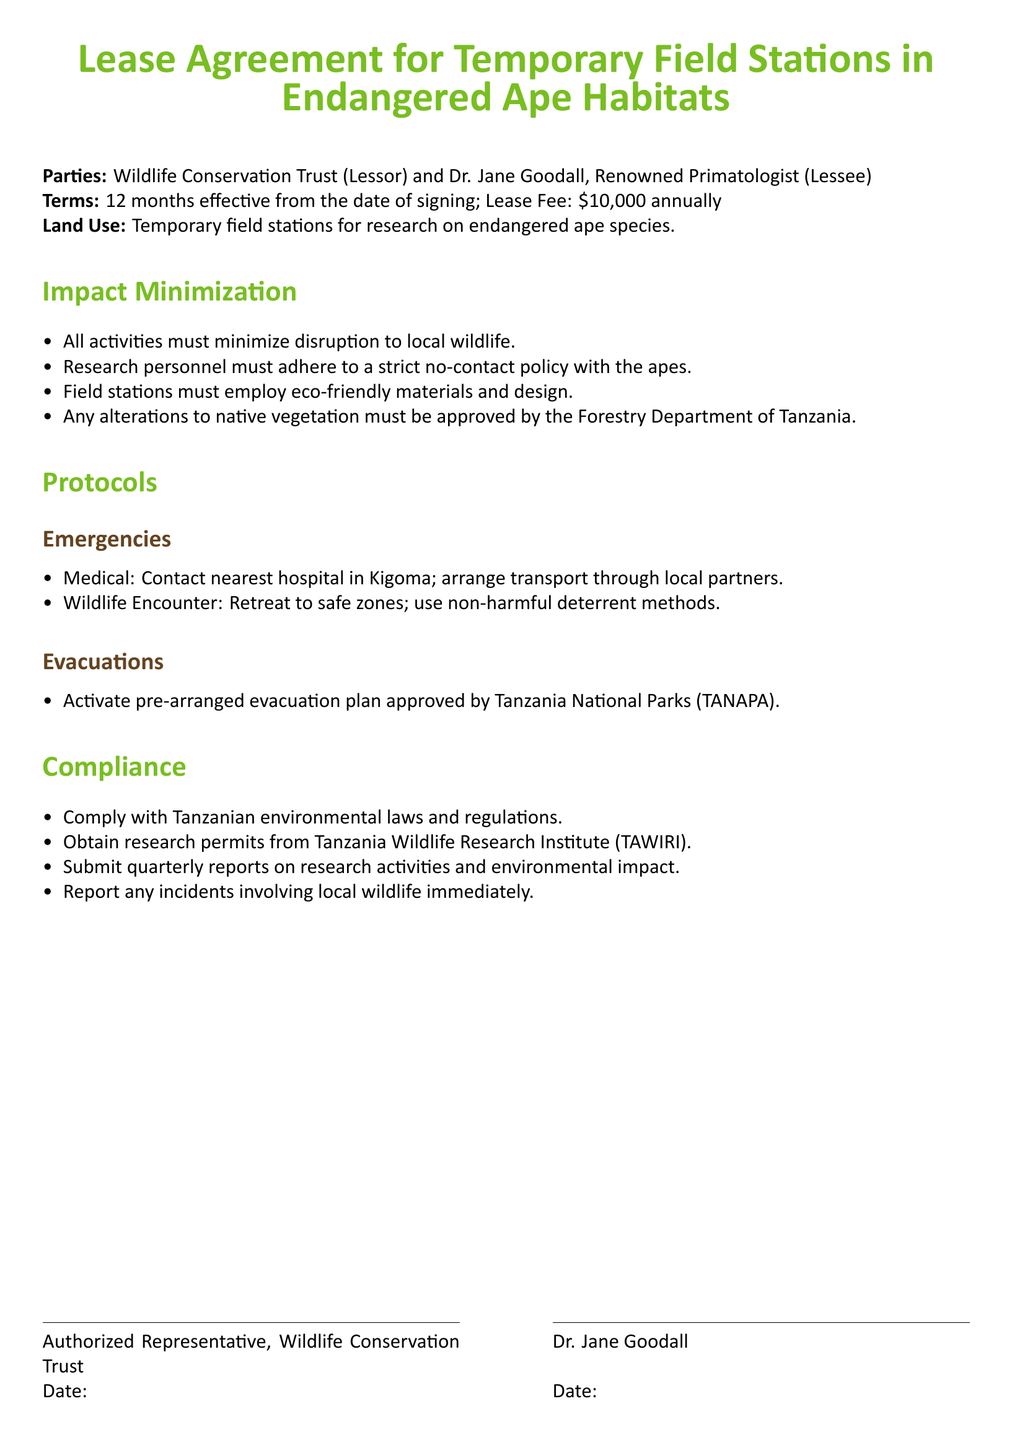What are the parties involved in the lease agreement? The parties are the Wildlife Conservation Trust (Lessor) and Dr. Jane Goodall (Lessee).
Answer: Wildlife Conservation Trust and Dr. Jane Goodall What is the duration of the lease? The lease is effective for 12 months from the date of signing.
Answer: 12 months What is the annual lease fee? The lease fee indicated in the document is stated as an annual amount.
Answer: $10,000 What must research personnel adhere to regarding local wildlife? There is a specific policy that research personnel must follow concerning interactions with the local wildlife.
Answer: strict no-contact policy Who must approve alterations to native vegetation? The document specifies an authority responsible for approving changes to native vegetation.
Answer: Forestry Department of Tanzania What should be done in case of a wildlife encounter? The document advises on a specific action to take during a wildlife encounter.
Answer: Retreat to safe zones Which organization must approve the evacuation plan? The document identifies an organization whose approval is necessary for evacuation plans related to the lease.
Answer: Tanzania National Parks (TANAPA) What is required regarding research permits? The document specifies a requirement related to permits before conducting research activities.
Answer: Obtain research permits What type of reports must be submitted quarterly? The lease agreement outlines a requirement concerning submissions of reports at certain intervals.
Answer: research activities and environmental impact 